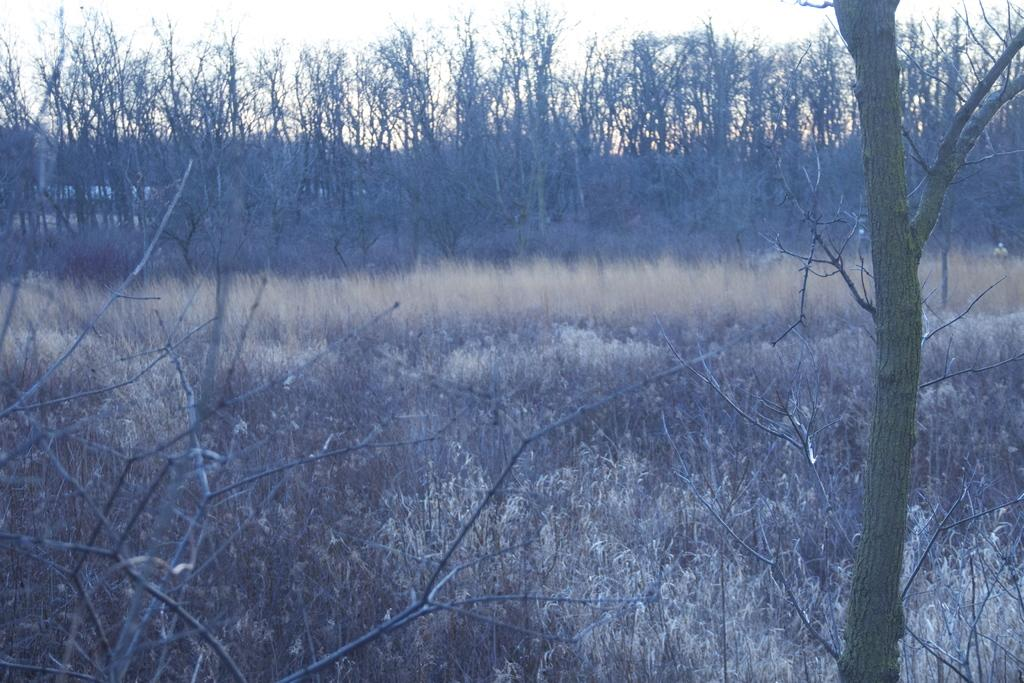What type of setting is depicted in the image? The image is an outside view. What can be seen at the bottom of the image? There is grass at the bottom of the image. Where is the tree trunk located in the image? The tree trunk is on the right side of the image. What is visible in the background of the image? There are many trees in the background of the image. What is visible at the top of the image? The sky is visible at the top of the image. What type of crime is being committed in the image? There is no crime being committed in the image; it is a peaceful outdoor scene. What type of bed can be seen in the image? There is no bed present in the image; it is an outdoor scene with grass, trees, and a tree trunk. 